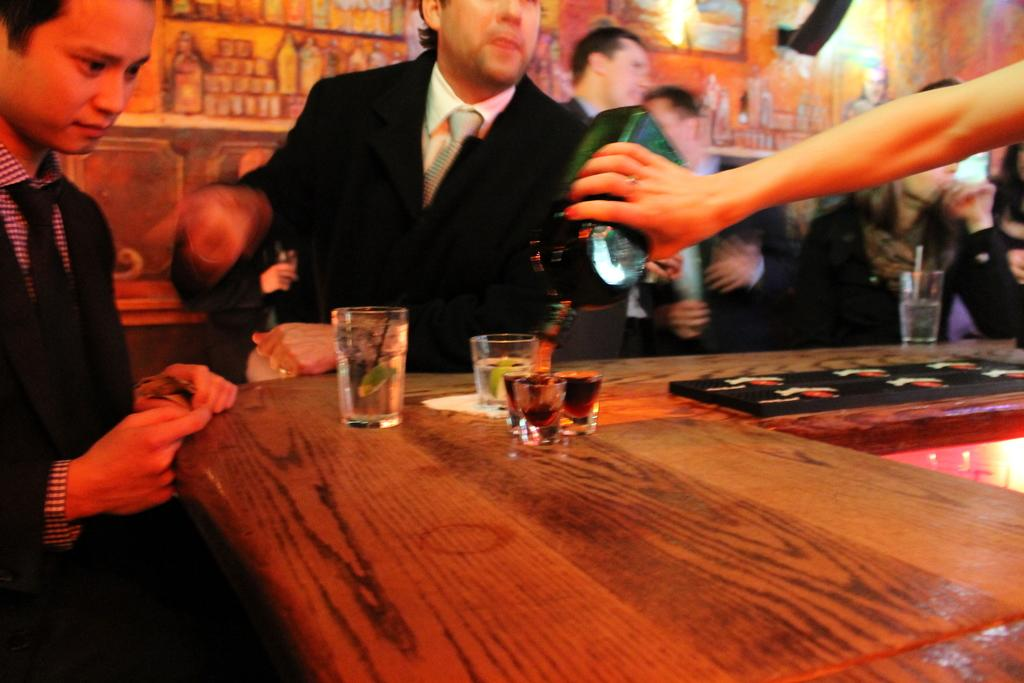What objects are on the table in the image? There are drinking glasses on the table. What can be seen near the table? There are people standing near the table. What is visible in the background of the image? There are paintings on a wall in the background. Where is the nest located in the image? There is no nest present in the image. What type of pot is being used to create the line in the image? There is no pot or line present in the image. 